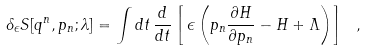Convert formula to latex. <formula><loc_0><loc_0><loc_500><loc_500>\delta _ { \epsilon } S [ q ^ { n } , p _ { n } ; \lambda ] = \int d t \, \frac { d } { d t } \left [ \, \epsilon \left ( p _ { n } \frac { \partial H } { \partial p _ { n } } - H + \Lambda \right ) \right ] \ ,</formula> 